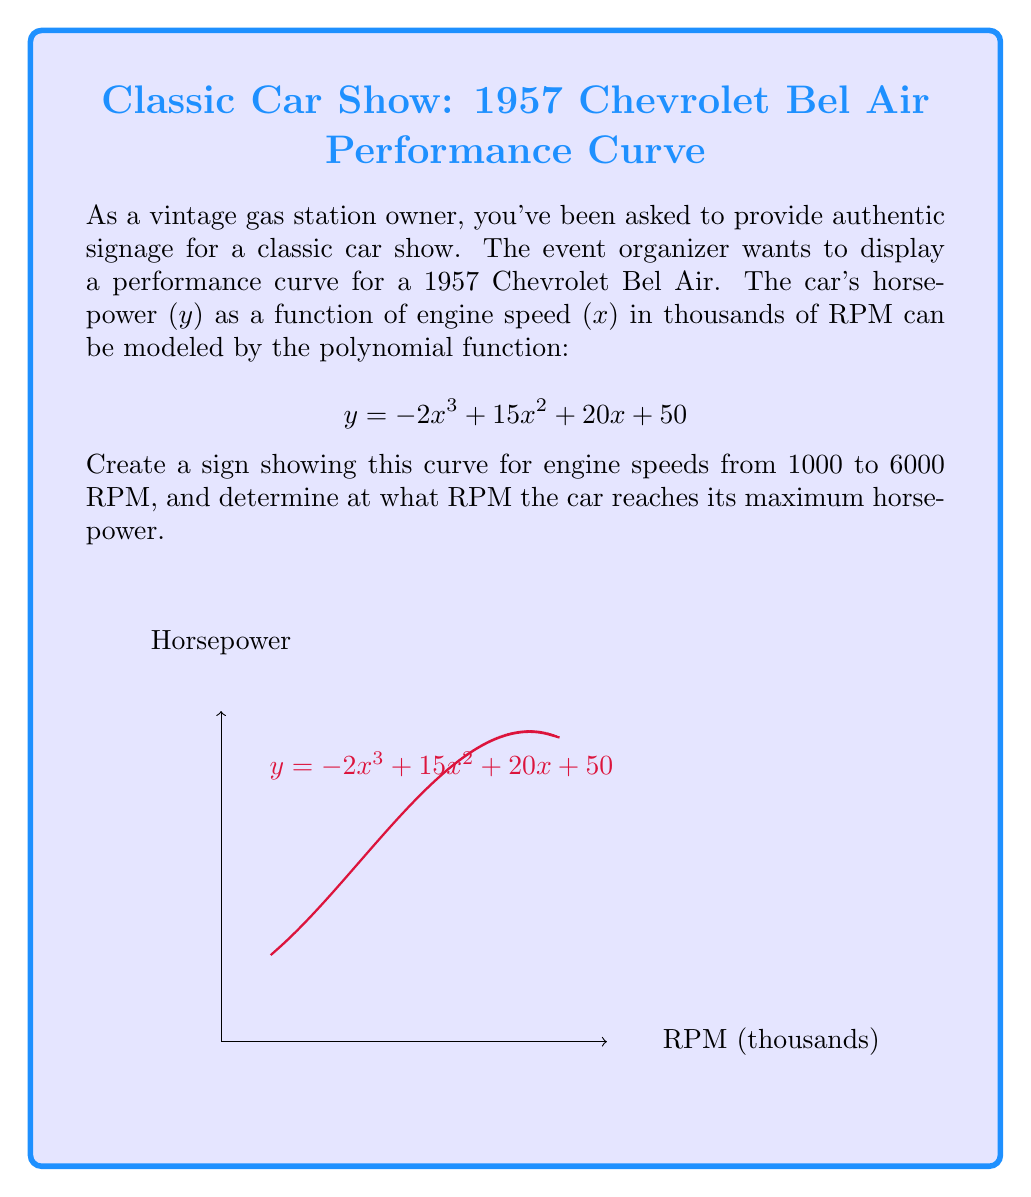Solve this math problem. To find the RPM at which the car reaches its maximum horsepower, we need to find the maximum of the function:

$$y = -2x^3 + 15x^2 + 20x + 50$$

1) First, let's find the derivative of this function:
   $$y' = -6x^2 + 30x + 20$$

2) To find the maximum, we set the derivative to zero and solve for x:
   $$-6x^2 + 30x + 20 = 0$$

3) This is a quadratic equation. We can solve it using the quadratic formula:
   $$x = \frac{-b \pm \sqrt{b^2 - 4ac}}{2a}$$
   where $a=-6$, $b=30$, and $c=20$

4) Plugging in these values:
   $$x = \frac{-30 \pm \sqrt{30^2 - 4(-6)(20)}}{2(-6)}$$
   $$= \frac{-30 \pm \sqrt{900 + 480}}{-12}$$
   $$= \frac{-30 \pm \sqrt{1380}}{-12}$$

5) Simplifying:
   $$x = \frac{-30 \pm 37.15}{-12}$$

6) This gives us two solutions:
   $$x_1 = \frac{-30 + 37.15}{-12} \approx 0.596$$
   $$x_2 = \frac{-30 - 37.15}{-12} \approx 5.596$$

7) The second solution (5.596) is the maximum point, as the function opens downward (negative coefficient for $x^3$).

8) Since x represents thousands of RPM, we multiply by 1000:
   5.596 * 1000 ≈ 5596 RPM

Therefore, the car reaches its maximum horsepower at approximately 5596 RPM.
Answer: 5596 RPM 